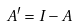Convert formula to latex. <formula><loc_0><loc_0><loc_500><loc_500>A ^ { \prime } = I - A</formula> 